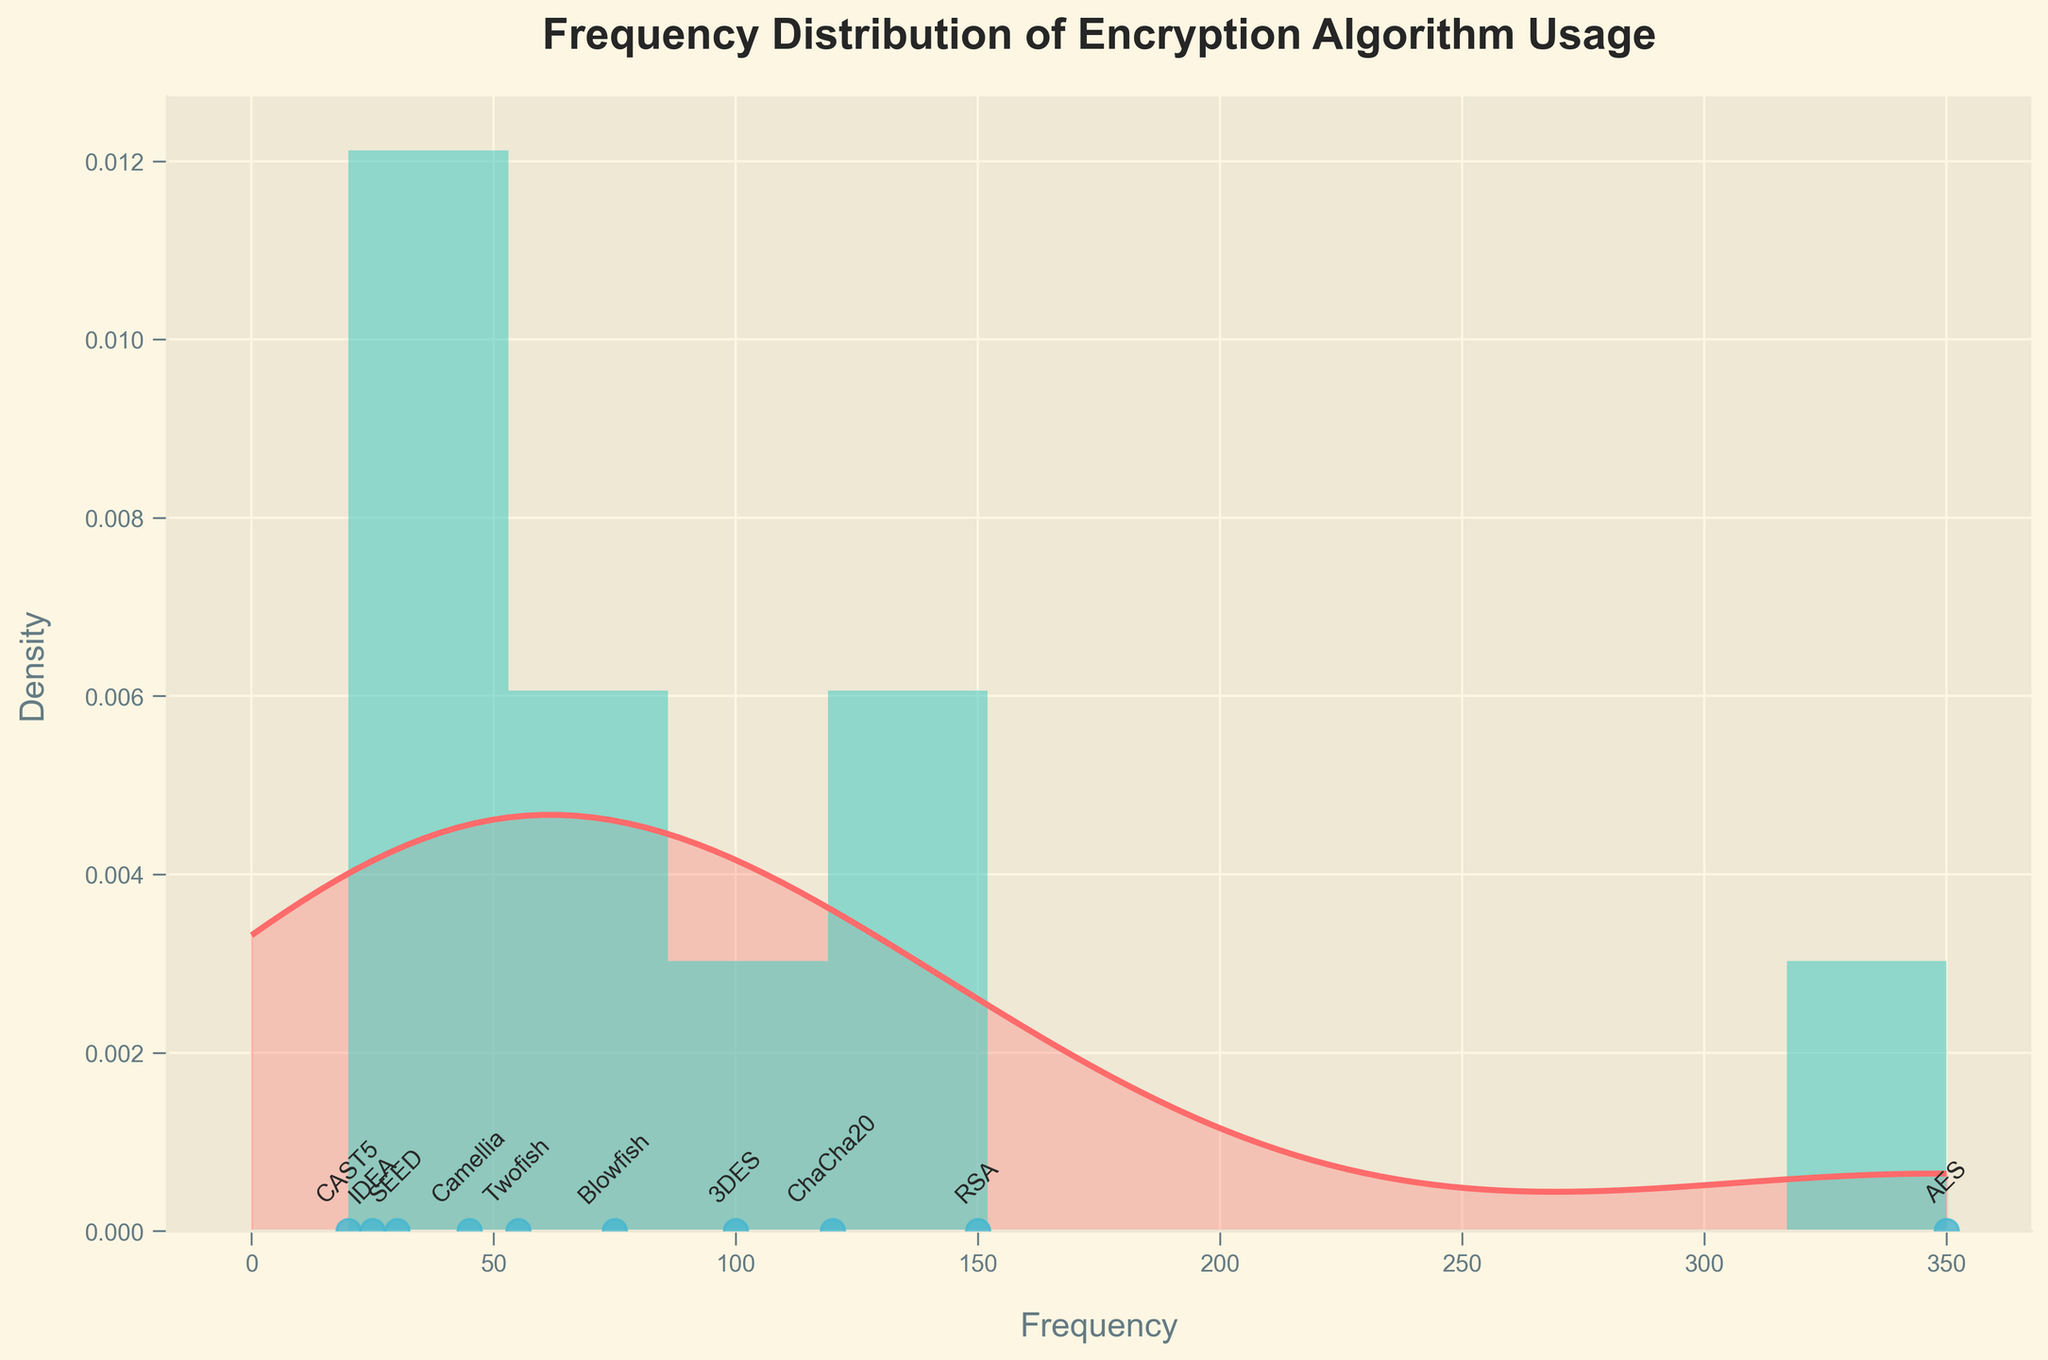What is the most frequently used encryption algorithm in the compromised datasets? The most frequently used encryption algorithm will be the one with the highest frequency value. Observing the histogram, AES appears to have the tallest bar, indicating the highest frequency of usage.
Answer: AES How many encryption algorithms have a usage frequency of less than 50? Count the number of bars in the histogram or scatter points below the 50 frequency mark. Camellia (45), SEED (30), IDEA (25), and CAST5 (20) are the ones below 50.
Answer: 4 Which encryption algorithm has the least frequency of usage? The algorithm with the smallest frequency value will be the least used. Looking at the histogram scatter points, CAST5, with a frequency of 20, is the smallest.
Answer: CAST5 What is the title of the plot? The title is always displayed prominently above the plot. In this case, it reads "Frequency Distribution of Encryption Algorithm Usage".
Answer: Frequency Distribution of Encryption Algorithm Usage What is the approximate density value at frequency 100? Look at the Gaussian KDE curve where it intersects with the frequency of 100 on the x-axis, and read the density value on the y-axis at this point.
Answer: Approx. 0.004 How many encryption algorithms have a frequency higher than RSA but lower than AES? Identify which has frequencies greater than RSA's 150 and less than AES's 350. ChaCha20, with 120, falls in this range.
Answer: 1 Which encryption algorithm usage frequency is closest to the mean frequency? Calculate the mean frequency by summing all the frequencies and dividing by the number of algorithms, then find the frequency value closest to this mean. Mean = (350+150+75+100+55+120+45+30+25+20)/10 = 97. ChaCha20 with 120 is the closest to the mean.
Answer: ChaCha20 Which encryption algorithms appear between 50 and 120 frequency range on the plot? Identify the algorithms whose frequencies lie between 50 and 120 by checking the histogram scatter points: Blowfish (75), 3DES (100), Twofish (55), and ChaCha20 (120).
Answer: Blowfish, 3DES, Twofish, ChaCha20 What color is used to represent the histogram bars in the plot? The histogram bars can be seen in the plot with a specific color. In this case, the bars are in a shade of green.
Answer: Green Which algorithms are labeled below the x-axis of the scatter plot, and how are they formatted? The scatter plot labels with the algorithms' names are found below each data point on the x-axis, and they are accompanied by vertical spacing and tilt.
Answer: All algorithm names are shown rotated at 45 degrees below their respective frequency points on the x-axis 